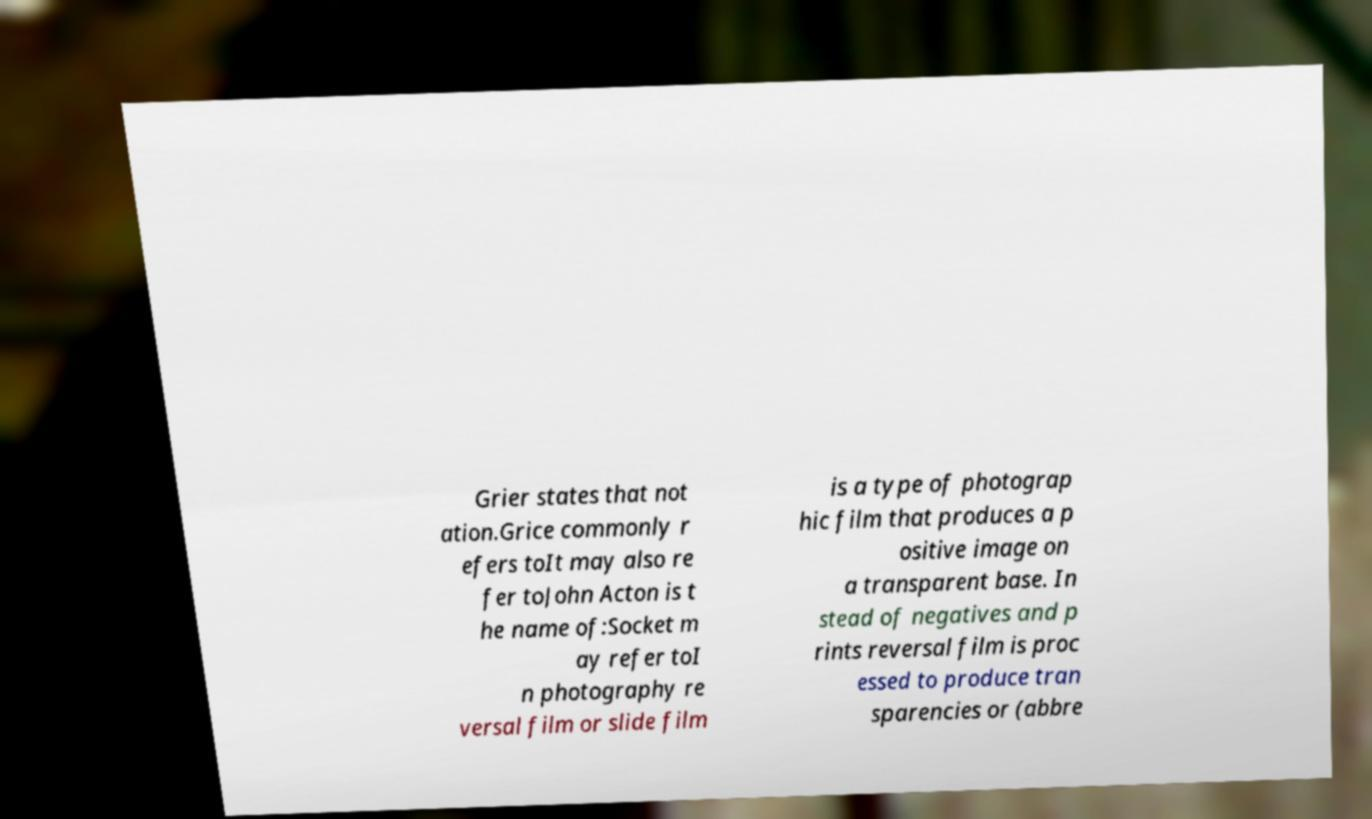Please identify and transcribe the text found in this image. Grier states that not ation.Grice commonly r efers toIt may also re fer toJohn Acton is t he name of:Socket m ay refer toI n photography re versal film or slide film is a type of photograp hic film that produces a p ositive image on a transparent base. In stead of negatives and p rints reversal film is proc essed to produce tran sparencies or (abbre 